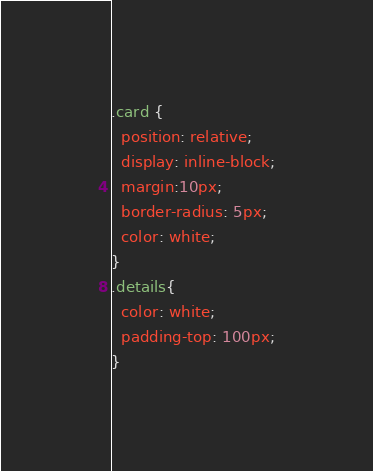<code> <loc_0><loc_0><loc_500><loc_500><_CSS_>.card {
  position: relative;
  display: inline-block;
  margin:10px;
  border-radius: 5px;
  color: white;
}
.details{
  color: white;
  padding-top: 100px;
}</code> 